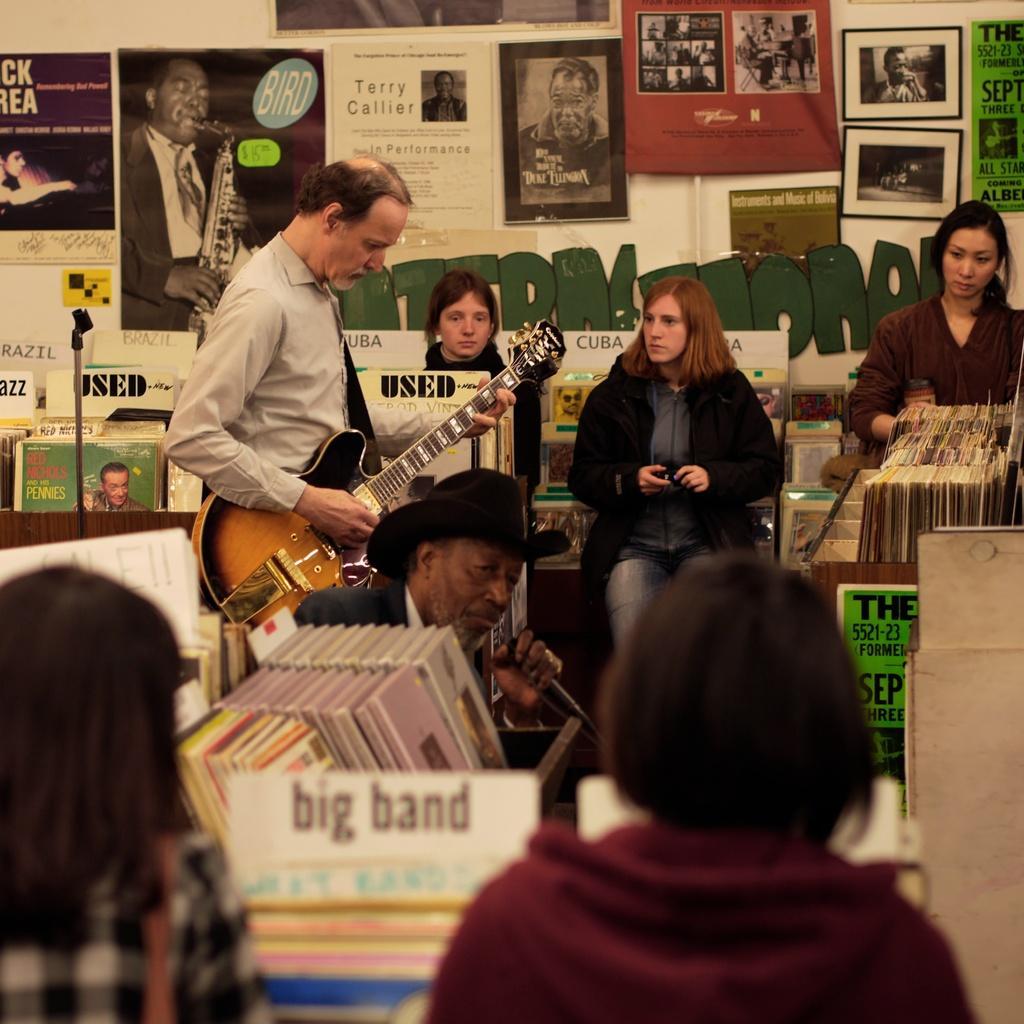Describe this image in one or two sentences. There are few people here. In them one is standing and playing guitar,other is holding microphone in his hand and the other 4 are women. On the wall we can see posters,frames and photographs and there are also books here in this room. 